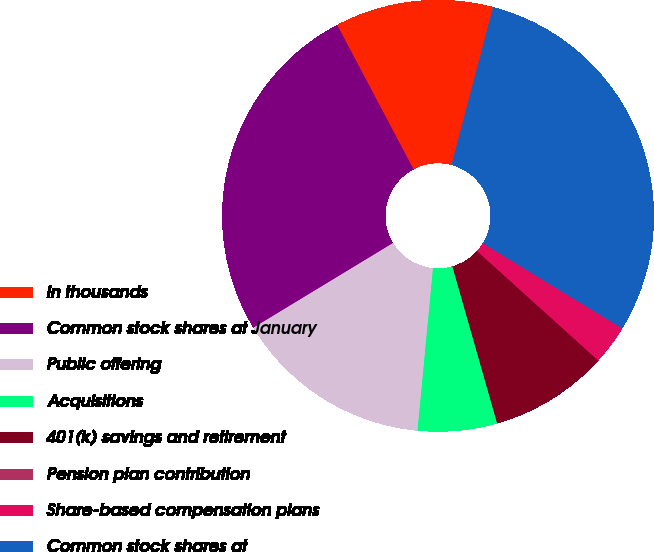<chart> <loc_0><loc_0><loc_500><loc_500><pie_chart><fcel>in thousands<fcel>Common stock shares at January<fcel>Public offering<fcel>Acquisitions<fcel>401(k) savings and retirement<fcel>Pension plan contribution<fcel>Share-based compensation plans<fcel>Common stock shares at<nl><fcel>11.85%<fcel>25.94%<fcel>14.81%<fcel>5.93%<fcel>8.89%<fcel>0.0%<fcel>2.96%<fcel>29.62%<nl></chart> 